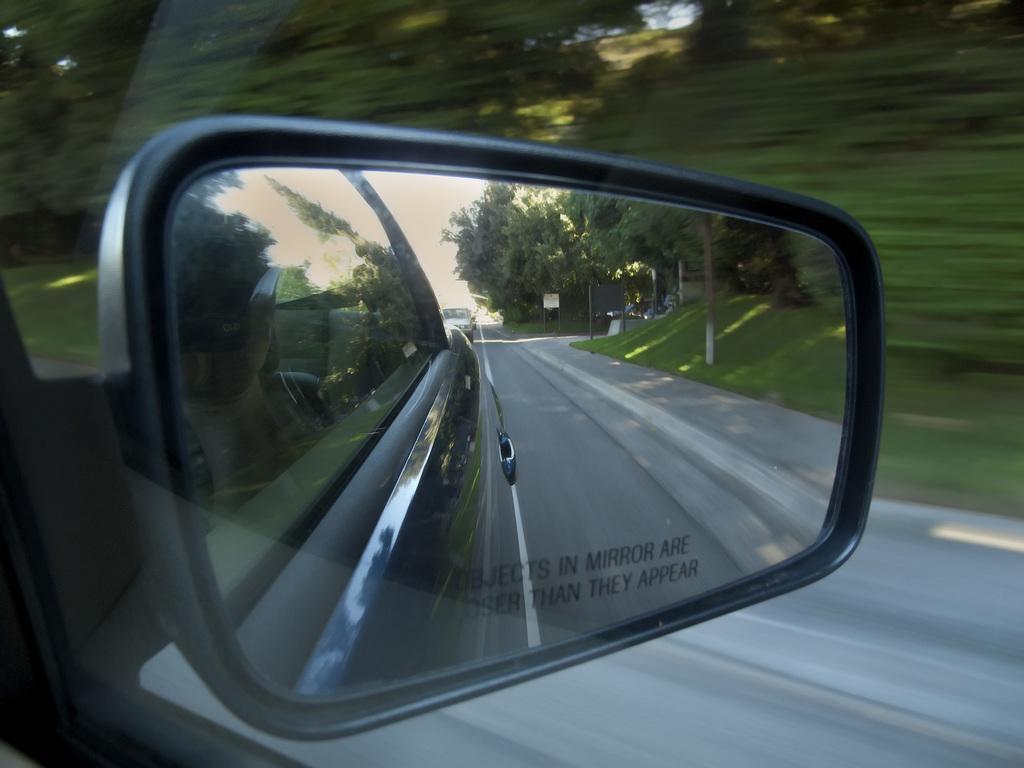In one or two sentences, can you explain what this image depicts? In this image we can see a side mirror of a car on which some text is written. While looking into the mirror, we can see the Group of trees, grass, road and the walkway on the road side. 